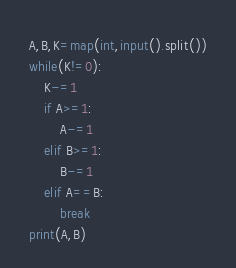Convert code to text. <code><loc_0><loc_0><loc_500><loc_500><_Python_>A,B,K=map(int,input().split())
while(K!=0):
	K-=1
	if A>=1:
		A-=1
	elif B>=1:
		B-=1
	elif A==B:
		break
print(A,B)</code> 